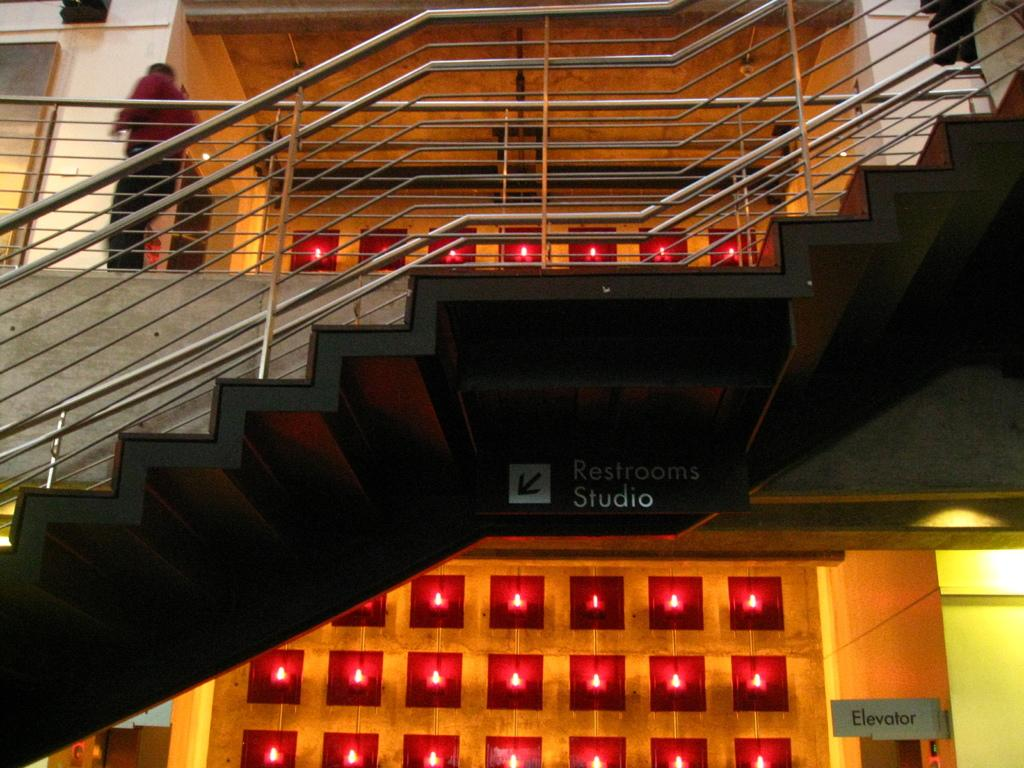What is the main subject of the image? There is a person standing in the image. What type of architectural feature is present in the image? There are stairs with staircase holders in the image. What is hanging from the roof in the image? There is a board hanging from the roof in the image. How is the wall decorated in the image? The wall appears to be decorated. What color is the shirt worn by the horses in the image? There are no horses present in the image, and therefore no shirts can be observed. 